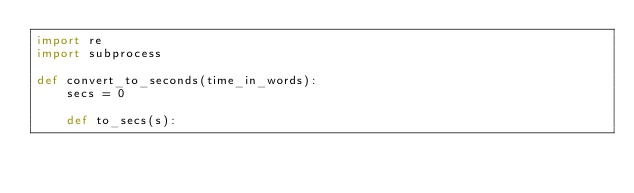Convert code to text. <code><loc_0><loc_0><loc_500><loc_500><_Python_>import re
import subprocess

def convert_to_seconds(time_in_words):
    secs = 0

    def to_secs(s):</code> 